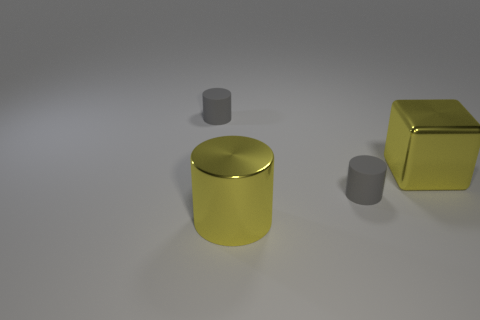The metallic thing that is the same color as the shiny cylinder is what shape?
Your response must be concise. Cube. There is a object that is the same color as the shiny cube; what material is it?
Ensure brevity in your answer.  Metal. Do the metal cylinder and the big metallic cube have the same color?
Your answer should be very brief. Yes. How many purple metal things are there?
Provide a succinct answer. 0. What is the material of the tiny cylinder that is left of the big yellow thing that is in front of the big shiny block?
Your answer should be compact. Rubber. There is a object that is the same size as the yellow metal block; what material is it?
Give a very brief answer. Metal. There is a yellow metal object on the right side of the yellow shiny cylinder; does it have the same size as the large yellow shiny cylinder?
Provide a succinct answer. Yes. What number of things are either purple metallic cylinders or tiny rubber cylinders that are on the right side of the yellow shiny cylinder?
Make the answer very short. 1. Is the number of small cylinders less than the number of large blocks?
Make the answer very short. No. Are there more big yellow blocks than cylinders?
Keep it short and to the point. No. 